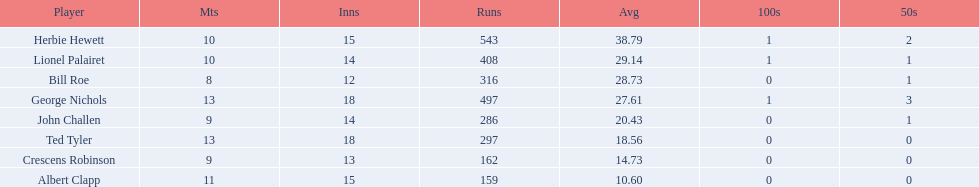What were the number of innings albert clapp had? 15. 